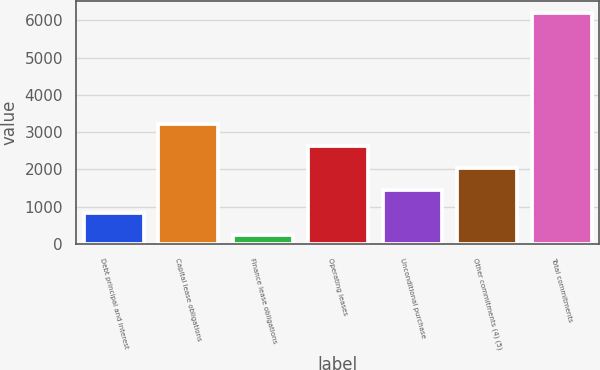<chart> <loc_0><loc_0><loc_500><loc_500><bar_chart><fcel>Debt principal and interest<fcel>Capital lease obligations<fcel>Finance lease obligations<fcel>Operating leases<fcel>Unconditional purchase<fcel>Other commitments (4) (5)<fcel>Total commitments<nl><fcel>840.5<fcel>3226.5<fcel>244<fcel>2630<fcel>1437<fcel>2033.5<fcel>6209<nl></chart> 